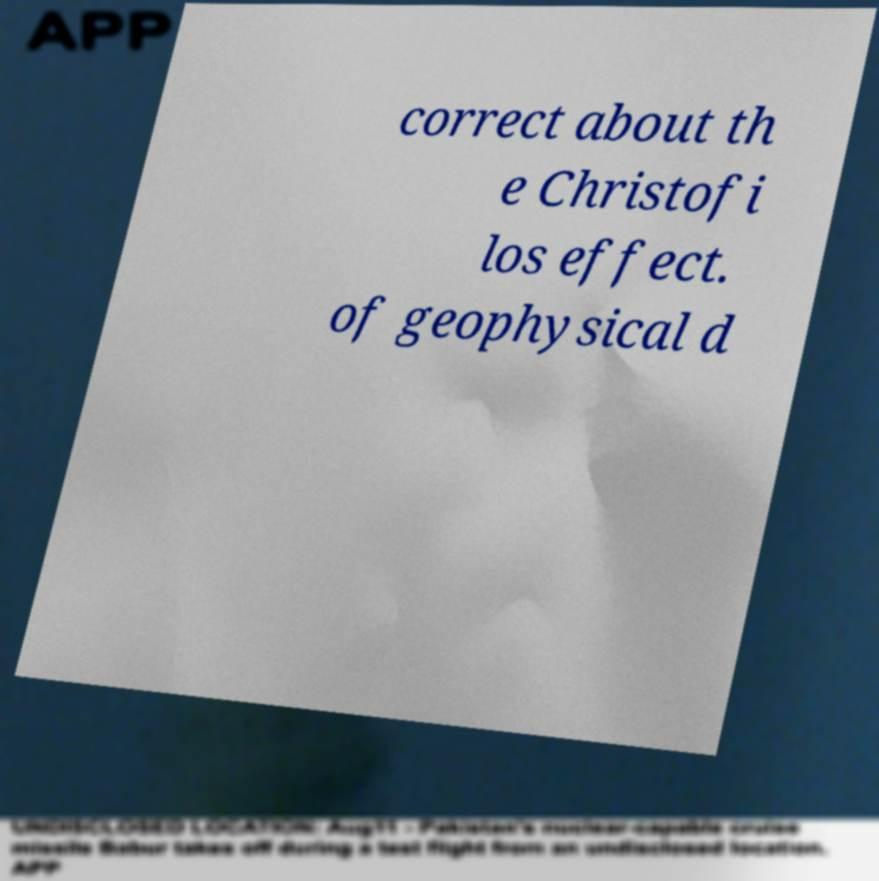Could you assist in decoding the text presented in this image and type it out clearly? correct about th e Christofi los effect. of geophysical d 